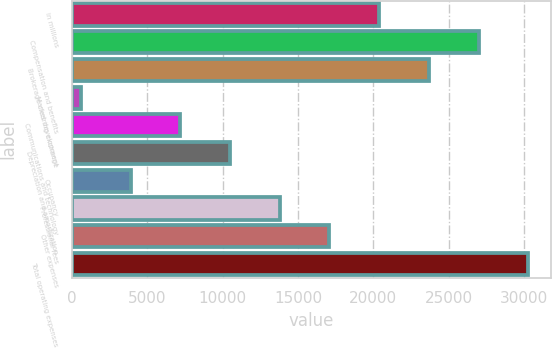<chart> <loc_0><loc_0><loc_500><loc_500><bar_chart><fcel>in millions<fcel>Compensation and benefits<fcel>Brokerage clearing exchange<fcel>Market development<fcel>Communications and technology<fcel>Depreciation and amortization<fcel>Occupancy<fcel>Professional fees<fcel>Other expenses<fcel>Total operating expenses<nl><fcel>20395.2<fcel>26997.6<fcel>23696.4<fcel>588<fcel>7190.4<fcel>10491.6<fcel>3889.2<fcel>13792.8<fcel>17094<fcel>30298.8<nl></chart> 